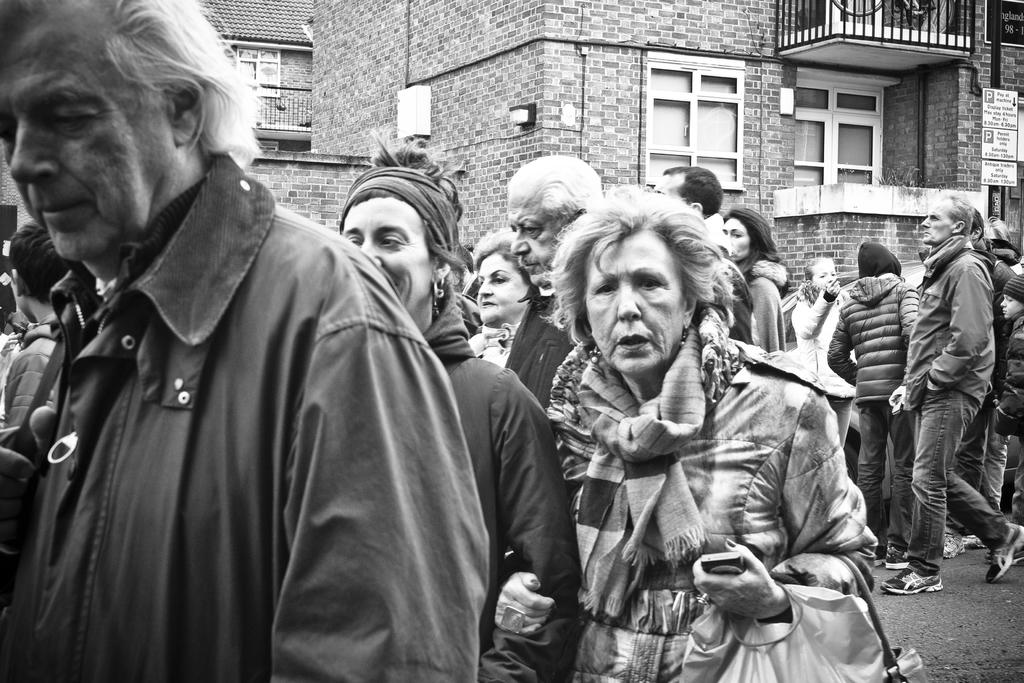What is happening with the group of people in the image? The people are walking and standing on a path in the image. What can be seen in the background of the image? There are buildings in the background of the image. What features do the buildings have? The buildings have windows and railings. What type of ice can be seen melting on the railings of the buildings in the image? There is no ice present on the railings of the buildings in the image. Can you spot a squirrel climbing on the windows of the buildings in the image? There is no squirrel visible on the windows of the buildings in the image. 